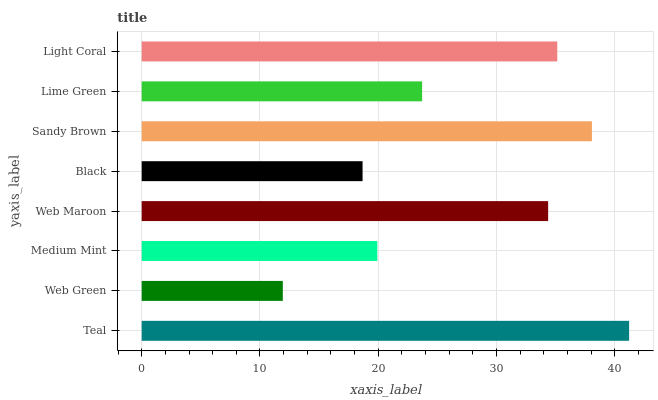Is Web Green the minimum?
Answer yes or no. Yes. Is Teal the maximum?
Answer yes or no. Yes. Is Medium Mint the minimum?
Answer yes or no. No. Is Medium Mint the maximum?
Answer yes or no. No. Is Medium Mint greater than Web Green?
Answer yes or no. Yes. Is Web Green less than Medium Mint?
Answer yes or no. Yes. Is Web Green greater than Medium Mint?
Answer yes or no. No. Is Medium Mint less than Web Green?
Answer yes or no. No. Is Web Maroon the high median?
Answer yes or no. Yes. Is Lime Green the low median?
Answer yes or no. Yes. Is Web Green the high median?
Answer yes or no. No. Is Web Green the low median?
Answer yes or no. No. 